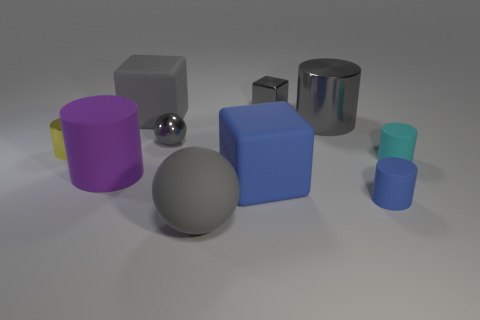What size is the gray cylinder that is made of the same material as the small sphere?
Make the answer very short. Large. There is another purple object that is the same shape as the big metallic object; what is its size?
Provide a succinct answer. Large. What is the size of the gray ball that is in front of the blue cube?
Provide a succinct answer. Large. There is a tiny object that is the same shape as the large blue rubber thing; what is its color?
Offer a terse response. Gray. How many rubber blocks have the same color as the metal cube?
Provide a short and direct response. 1. Are there any cylinders that are in front of the gray sphere on the left side of the gray rubber object that is to the right of the tiny gray sphere?
Give a very brief answer. Yes. How many big gray balls have the same material as the blue cylinder?
Provide a short and direct response. 1. Does the gray sphere in front of the cyan matte object have the same size as the thing on the right side of the tiny blue rubber cylinder?
Keep it short and to the point. No. There is a rubber cube that is in front of the ball that is behind the gray object in front of the purple thing; what color is it?
Give a very brief answer. Blue. Is there a matte object of the same shape as the tiny yellow metallic thing?
Your answer should be very brief. Yes. 